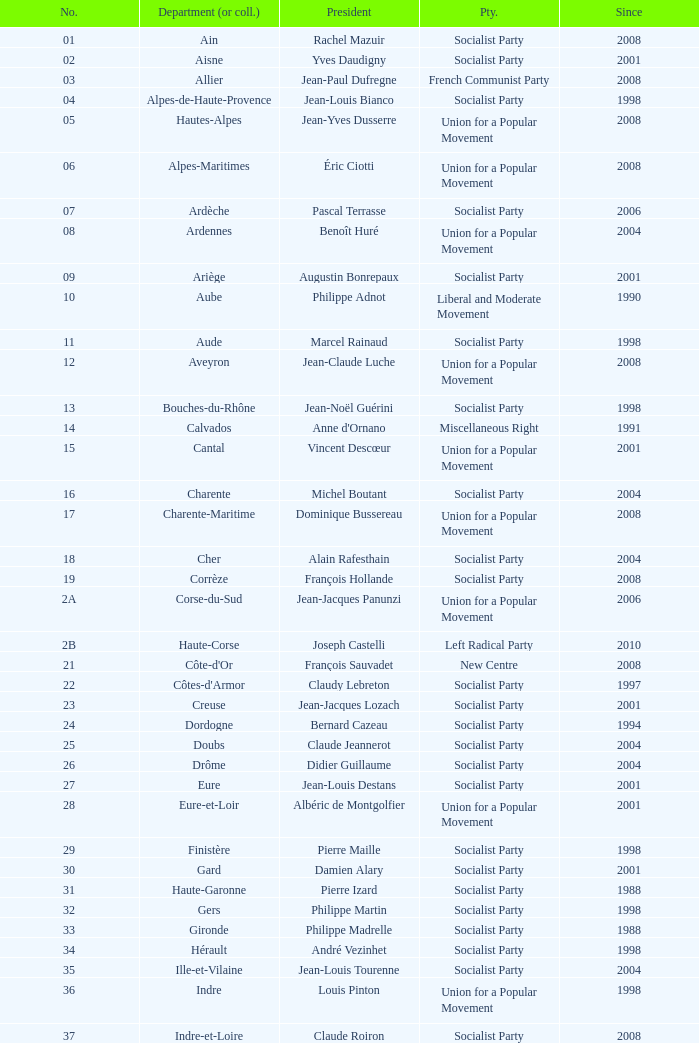What number corresponds to Presidet Yves Krattinger of the Socialist party? 70.0. Give me the full table as a dictionary. {'header': ['No.', 'Department (or coll.)', 'President', 'Pty.', 'Since'], 'rows': [['01', 'Ain', 'Rachel Mazuir', 'Socialist Party', '2008'], ['02', 'Aisne', 'Yves Daudigny', 'Socialist Party', '2001'], ['03', 'Allier', 'Jean-Paul Dufregne', 'French Communist Party', '2008'], ['04', 'Alpes-de-Haute-Provence', 'Jean-Louis Bianco', 'Socialist Party', '1998'], ['05', 'Hautes-Alpes', 'Jean-Yves Dusserre', 'Union for a Popular Movement', '2008'], ['06', 'Alpes-Maritimes', 'Éric Ciotti', 'Union for a Popular Movement', '2008'], ['07', 'Ardèche', 'Pascal Terrasse', 'Socialist Party', '2006'], ['08', 'Ardennes', 'Benoît Huré', 'Union for a Popular Movement', '2004'], ['09', 'Ariège', 'Augustin Bonrepaux', 'Socialist Party', '2001'], ['10', 'Aube', 'Philippe Adnot', 'Liberal and Moderate Movement', '1990'], ['11', 'Aude', 'Marcel Rainaud', 'Socialist Party', '1998'], ['12', 'Aveyron', 'Jean-Claude Luche', 'Union for a Popular Movement', '2008'], ['13', 'Bouches-du-Rhône', 'Jean-Noël Guérini', 'Socialist Party', '1998'], ['14', 'Calvados', "Anne d'Ornano", 'Miscellaneous Right', '1991'], ['15', 'Cantal', 'Vincent Descœur', 'Union for a Popular Movement', '2001'], ['16', 'Charente', 'Michel Boutant', 'Socialist Party', '2004'], ['17', 'Charente-Maritime', 'Dominique Bussereau', 'Union for a Popular Movement', '2008'], ['18', 'Cher', 'Alain Rafesthain', 'Socialist Party', '2004'], ['19', 'Corrèze', 'François Hollande', 'Socialist Party', '2008'], ['2A', 'Corse-du-Sud', 'Jean-Jacques Panunzi', 'Union for a Popular Movement', '2006'], ['2B', 'Haute-Corse', 'Joseph Castelli', 'Left Radical Party', '2010'], ['21', "Côte-d'Or", 'François Sauvadet', 'New Centre', '2008'], ['22', "Côtes-d'Armor", 'Claudy Lebreton', 'Socialist Party', '1997'], ['23', 'Creuse', 'Jean-Jacques Lozach', 'Socialist Party', '2001'], ['24', 'Dordogne', 'Bernard Cazeau', 'Socialist Party', '1994'], ['25', 'Doubs', 'Claude Jeannerot', 'Socialist Party', '2004'], ['26', 'Drôme', 'Didier Guillaume', 'Socialist Party', '2004'], ['27', 'Eure', 'Jean-Louis Destans', 'Socialist Party', '2001'], ['28', 'Eure-et-Loir', 'Albéric de Montgolfier', 'Union for a Popular Movement', '2001'], ['29', 'Finistère', 'Pierre Maille', 'Socialist Party', '1998'], ['30', 'Gard', 'Damien Alary', 'Socialist Party', '2001'], ['31', 'Haute-Garonne', 'Pierre Izard', 'Socialist Party', '1988'], ['32', 'Gers', 'Philippe Martin', 'Socialist Party', '1998'], ['33', 'Gironde', 'Philippe Madrelle', 'Socialist Party', '1988'], ['34', 'Hérault', 'André Vezinhet', 'Socialist Party', '1998'], ['35', 'Ille-et-Vilaine', 'Jean-Louis Tourenne', 'Socialist Party', '2004'], ['36', 'Indre', 'Louis Pinton', 'Union for a Popular Movement', '1998'], ['37', 'Indre-et-Loire', 'Claude Roiron', 'Socialist Party', '2008'], ['38', 'Isère', 'André Vallini', 'Socialist Party', '2001'], ['39', 'Jura', 'Jean Raquin', 'Miscellaneous Right', '2008'], ['40', 'Landes', 'Henri Emmanuelli', 'Socialist Party', '1982'], ['41', 'Loir-et-Cher', 'Maurice Leroy', 'New Centre', '2004'], ['42', 'Loire', 'Bernard Bonne', 'Union for a Popular Movement', '2008'], ['43', 'Haute-Loire', 'Gérard Roche', 'Union for a Popular Movement', '2004'], ['44', 'Loire-Atlantique', 'Patrick Mareschal', 'Socialist Party', '2004'], ['45', 'Loiret', 'Éric Doligé', 'Union for a Popular Movement', '1994'], ['46', 'Lot', 'Gérard Miquel', 'Socialist Party', '2004'], ['47', 'Lot-et-Garonne', 'Pierre Camani', 'Socialist Party', '2008'], ['48', 'Lozère', 'Jean-Paul Pourquier', 'Union for a Popular Movement', '2004'], ['49', 'Maine-et-Loire', 'Christophe Béchu', 'Union for a Popular Movement', '2004'], ['50', 'Manche', 'Jean-François Le Grand', 'Union for a Popular Movement', '1998'], ['51', 'Marne', 'René-Paul Savary', 'Union for a Popular Movement', '2003'], ['52', 'Haute-Marne', 'Bruno Sido', 'Union for a Popular Movement', '1998'], ['53', 'Mayenne', 'Jean Arthuis', 'Miscellaneous Centre', '1992'], ['54', 'Meurthe-et-Moselle', 'Michel Dinet', 'Socialist Party', '1998'], ['55', 'Meuse', 'Christian Namy', 'Miscellaneous Right', '2004'], ['56', 'Morbihan', 'Joseph-François Kerguéris', 'Democratic Movement', '2004'], ['57', 'Moselle', 'Philippe Leroy', 'Union for a Popular Movement', '1992'], ['58', 'Nièvre', 'Marcel Charmant', 'Socialist Party', '2001'], ['59', 'Nord', 'Patrick Kanner', 'Socialist Party', '1998'], ['60', 'Oise', 'Yves Rome', 'Socialist Party', '2004'], ['61', 'Orne', 'Alain Lambert', 'Union for a Popular Movement', '2007'], ['62', 'Pas-de-Calais', 'Dominique Dupilet', 'Socialist Party', '2004'], ['63', 'Puy-de-Dôme', 'Jean-Yves Gouttebel', 'Socialist Party', '2004'], ['64', 'Pyrénées-Atlantiques', 'Jean Castaings', 'Union for a Popular Movement', '2008'], ['65', 'Hautes-Pyrénées', 'Josette Durrieu', 'Socialist Party', '2008'], ['66', 'Pyrénées-Orientales', 'Christian Bourquin', 'Socialist Party', '1998'], ['67', 'Bas-Rhin', 'Guy-Dominique Kennel', 'Union for a Popular Movement', '2008'], ['68', 'Haut-Rhin', 'Charles Buttner', 'Union for a Popular Movement', '2004'], ['69', 'Rhône', 'Michel Mercier', 'Miscellaneous Centre', '1990'], ['70', 'Haute-Saône', 'Yves Krattinger', 'Socialist Party', '2002'], ['71', 'Saône-et-Loire', 'Arnaud Montebourg', 'Socialist Party', '2008'], ['72', 'Sarthe', 'Roland du Luart', 'Union for a Popular Movement', '1998'], ['73', 'Savoie', 'Hervé Gaymard', 'Union for a Popular Movement', '2008'], ['74', 'Haute-Savoie', 'Christian Monteil', 'Miscellaneous Right', '2008'], ['75', 'Paris', 'Bertrand Delanoë', 'Socialist Party', '2001'], ['76', 'Seine-Maritime', 'Didier Marie', 'Socialist Party', '2004'], ['77', 'Seine-et-Marne', 'Vincent Eblé', 'Socialist Party', '2004'], ['78', 'Yvelines', 'Pierre Bédier', 'Union for a Popular Movement', '2005'], ['79', 'Deux-Sèvres', 'Éric Gautier', 'Socialist Party', '2008'], ['80', 'Somme', 'Christian Manable', 'Socialist Party', '2008'], ['81', 'Tarn', 'Thierry Carcenac', 'Socialist Party', '1991'], ['82', 'Tarn-et-Garonne', 'Jean-Michel Baylet', 'Left Radical Party', '1986'], ['83', 'Var', 'Horace Lanfranchi', 'Union for a Popular Movement', '2002'], ['84', 'Vaucluse', 'Claude Haut', 'Socialist Party', '2001'], ['85', 'Vendée', 'Philippe de Villiers', 'Movement for France', '1988'], ['86', 'Vienne', 'Claude Bertaud', 'Union for a Popular Movement', '2008'], ['87', 'Haute-Vienne', 'Marie-Françoise Pérol-Dumont', 'Socialist Party', '2004'], ['88', 'Vosges', 'Christian Poncelet', 'Union for a Popular Movement', '1976'], ['89', 'Yonne', 'Jean-Marie Rolland', 'Union for a Popular Movement', '2008'], ['90', 'Territoire de Belfort', 'Yves Ackermann', 'Socialist Party', '2004'], ['91', 'Essonne', 'Michel Berson', 'Socialist Party', '1998'], ['92', 'Hauts-de-Seine', 'Patrick Devedjian', 'Union for a Popular Movement', '2007'], ['93', 'Seine-Saint-Denis', 'Claude Bartolone', 'Socialist Party', '2008'], ['94', 'Val-de-Marne', 'Christian Favier', 'French Communist Party', '2001'], ['95', 'Val-d’Oise', 'Arnaud Bazin', 'Union for a Popular Movement', '2011'], ['971', 'Guadeloupe', 'Jacques Gillot', 'United Guadeloupe, Socialism and Realities', '2001'], ['972', 'Martinique', 'Claude Lise', 'Martinican Democratic Rally', '1992'], ['973', 'Guyane', 'Alain Tien-Liong', 'Miscellaneous Left', '2008'], ['974', 'Réunion', 'Nassimah Dindar', 'Union for a Popular Movement', '2004'], ['975', 'Saint-Pierre-et-Miquelon (overseas collect.)', 'Stéphane Artano', 'Archipelago Tomorrow', '2006'], ['976', 'Mayotte (overseas collect.)', 'Ahmed Attoumani Douchina', 'Union for a Popular Movement', '2008']]} 